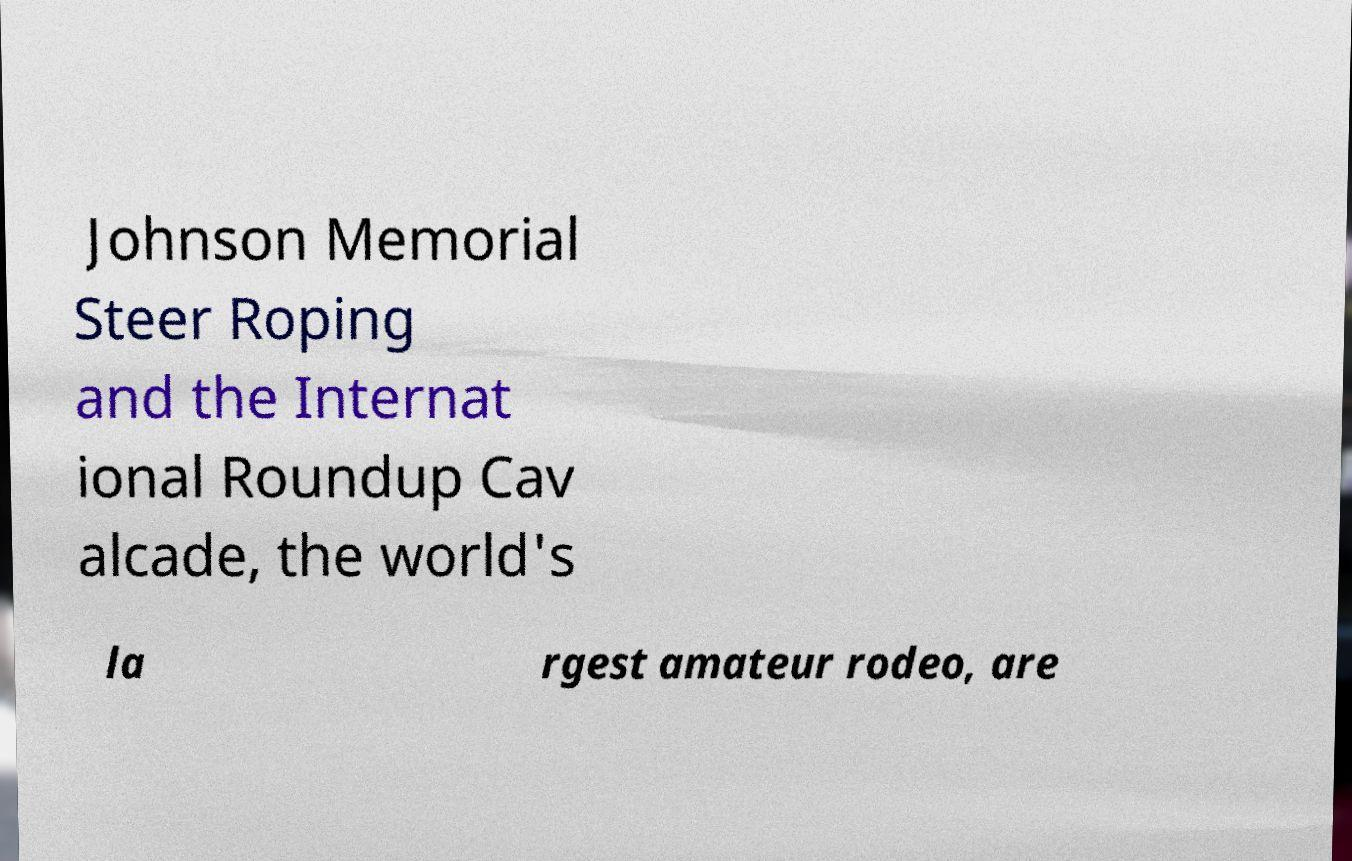Could you assist in decoding the text presented in this image and type it out clearly? Johnson Memorial Steer Roping and the Internat ional Roundup Cav alcade, the world's la rgest amateur rodeo, are 